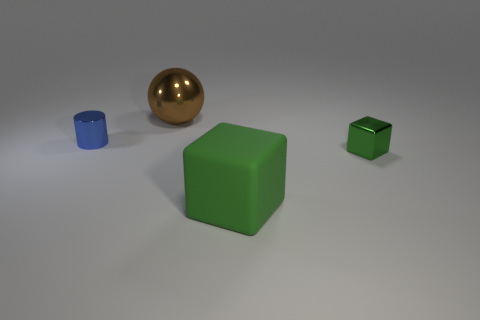There is a large object that is in front of the large thing that is behind the tiny blue shiny thing; what is its color?
Keep it short and to the point. Green. There is a green block that is behind the green object in front of the small object that is on the right side of the large ball; how big is it?
Offer a terse response. Small. Are there fewer big brown shiny spheres in front of the tiny blue cylinder than blue metallic objects in front of the shiny cube?
Offer a very short reply. No. How many other cylinders are made of the same material as the cylinder?
Offer a very short reply. 0. There is a brown metallic ball that is on the left side of the green object that is in front of the green metallic cube; are there any big brown metal things that are behind it?
Provide a short and direct response. No. There is a large brown thing that is the same material as the tiny green block; what shape is it?
Provide a succinct answer. Sphere. Is the number of purple spheres greater than the number of brown metal things?
Ensure brevity in your answer.  No. Do the small blue shiny object and the tiny shiny object to the right of the small cylinder have the same shape?
Your response must be concise. No. What material is the large brown thing?
Your answer should be compact. Metal. What is the color of the tiny shiny object on the right side of the thing that is in front of the green block that is on the right side of the green matte cube?
Provide a short and direct response. Green. 